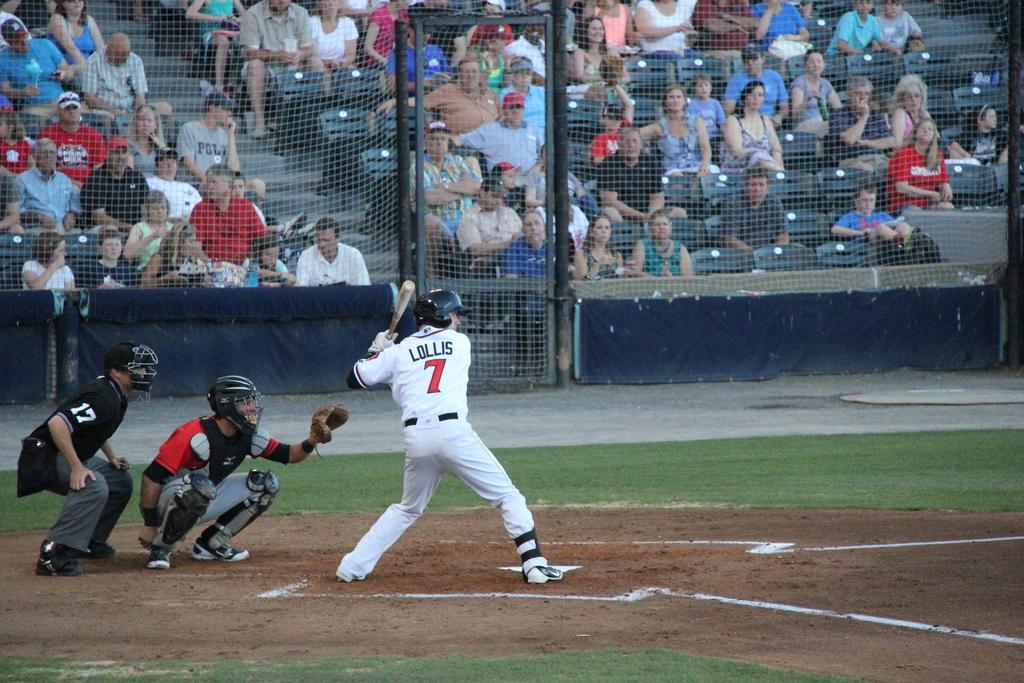<image>
Write a terse but informative summary of the picture. In the number 7 jersey, Lollis is taking his turn at bat. 